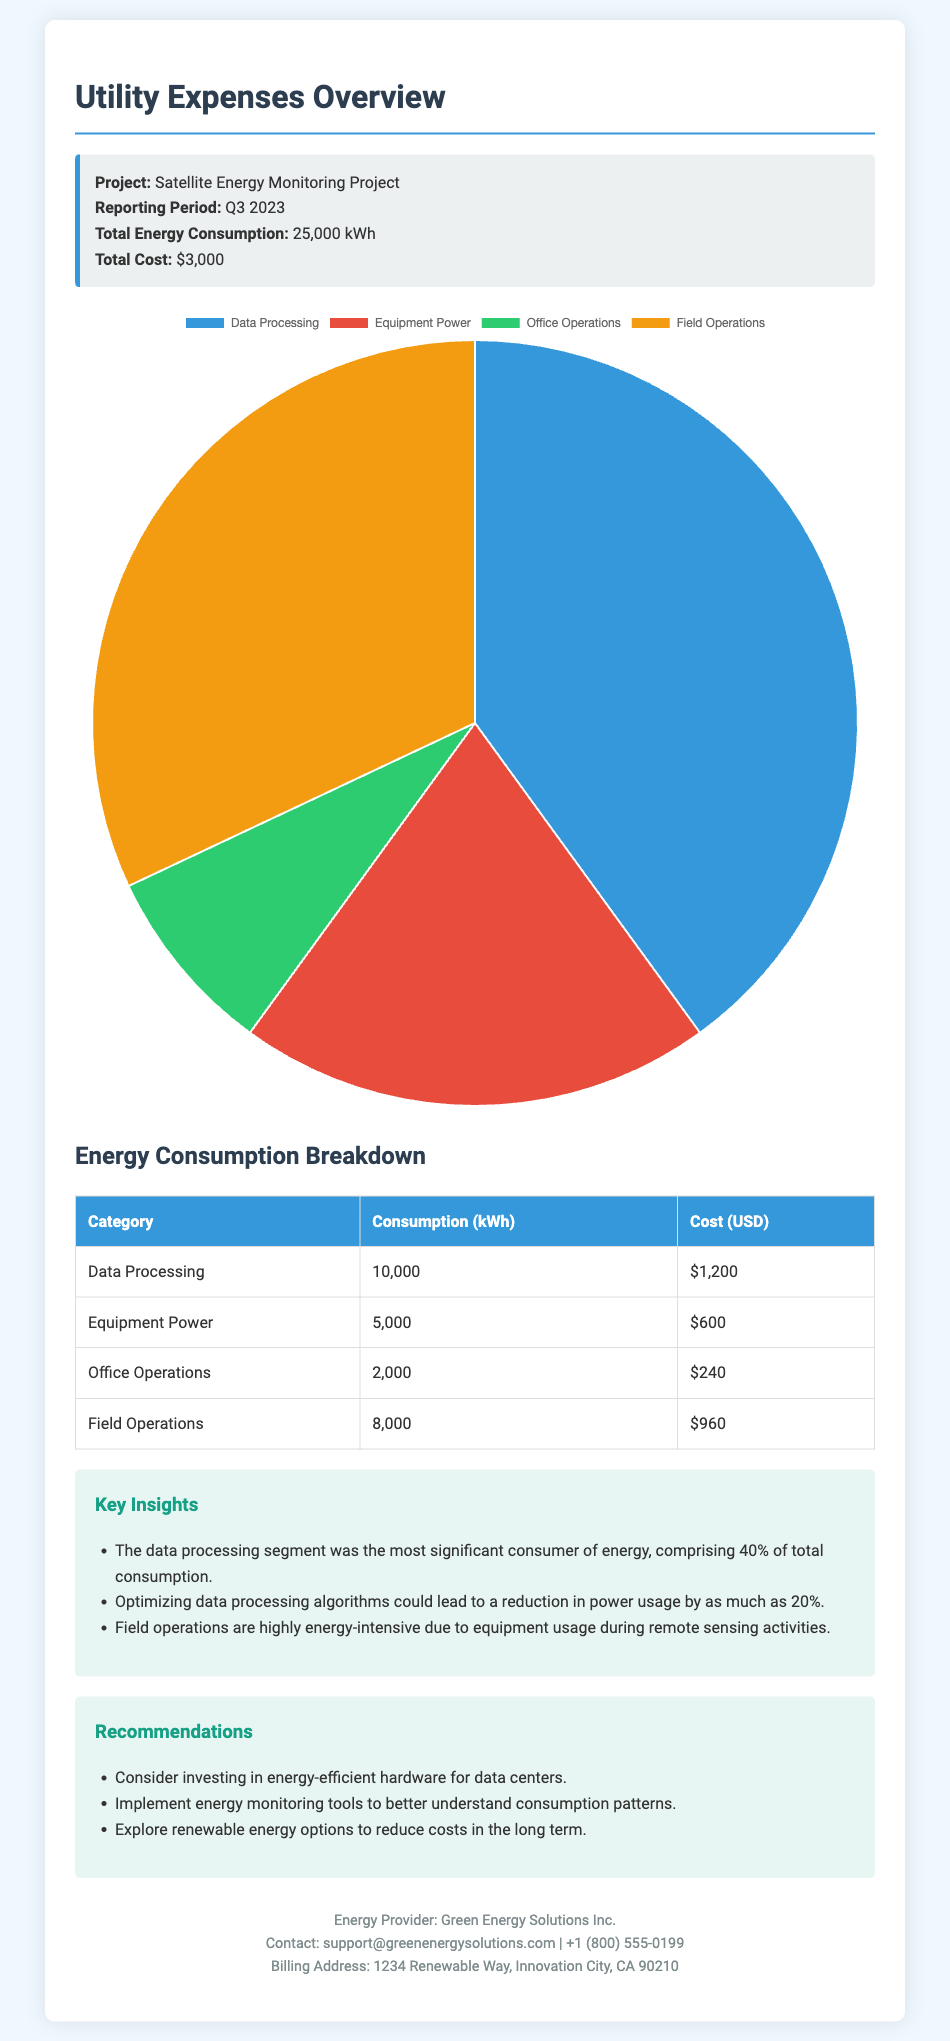what is the total energy consumption? The total energy consumption reported in the document for Q3 2023 is 25,000 kWh.
Answer: 25,000 kWh what is the total cost of utility expenses? The total cost for the utility expenses in Q3 2023 is stated as $3,000.
Answer: $3,000 which category consumed the most energy? The category that consumed the most energy is Data Processing, representing 10,000 kWh.
Answer: Data Processing what percentage of total consumption does Data Processing represent? Data Processing comprises 40% of the total energy consumption of 25,000 kWh.
Answer: 40% how much was spent on Field Operations? The cost incurred for Field Operations as detailed in the document is $960.
Answer: $960 what is the primary recommendation for reducing energy costs? One primary recommendation mentioned is to consider investing in energy-efficient hardware for data centers.
Answer: Energy-efficient hardware who is the energy provider listed in the document? The energy provider named in the document is Green Energy Solutions Inc.
Answer: Green Energy Solutions Inc which period is the report covering? The report covers the period noted as Q3 2023.
Answer: Q3 2023 how many kWh were consumed for Office Operations? The consumption for Office Operations as presented in the document is 2,000 kWh.
Answer: 2,000 kWh 